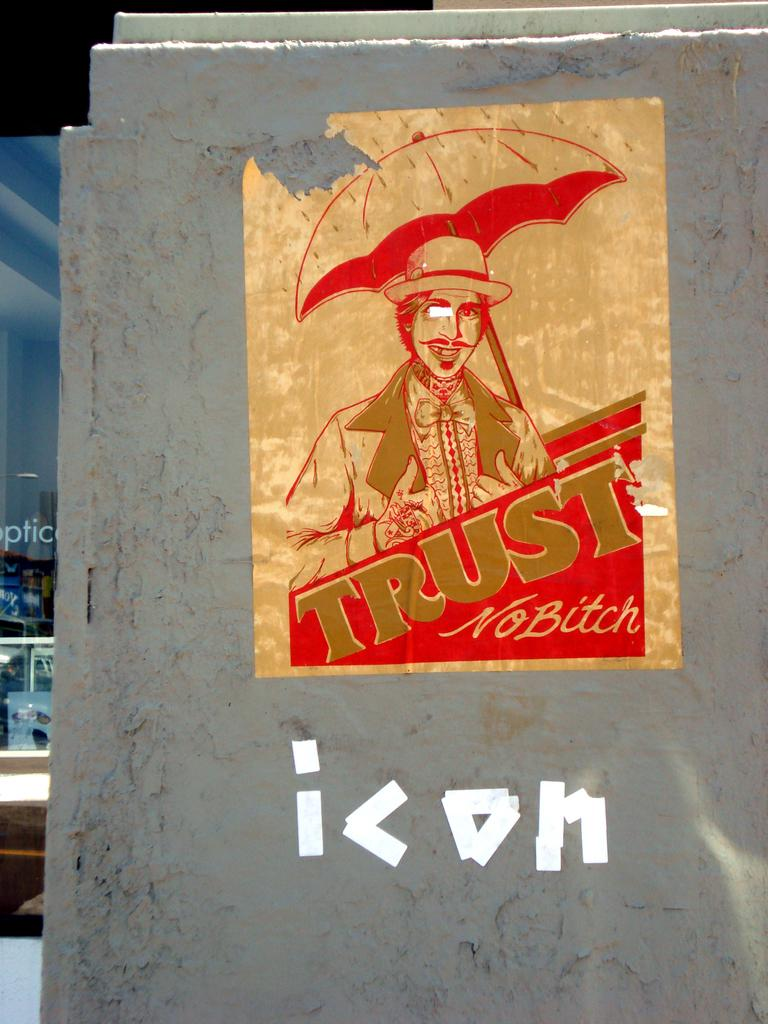<image>
Render a clear and concise summary of the photo. A gold and red vintage sticker on a wall of a man with an umbrella and some tape under it to write out the word icon. 